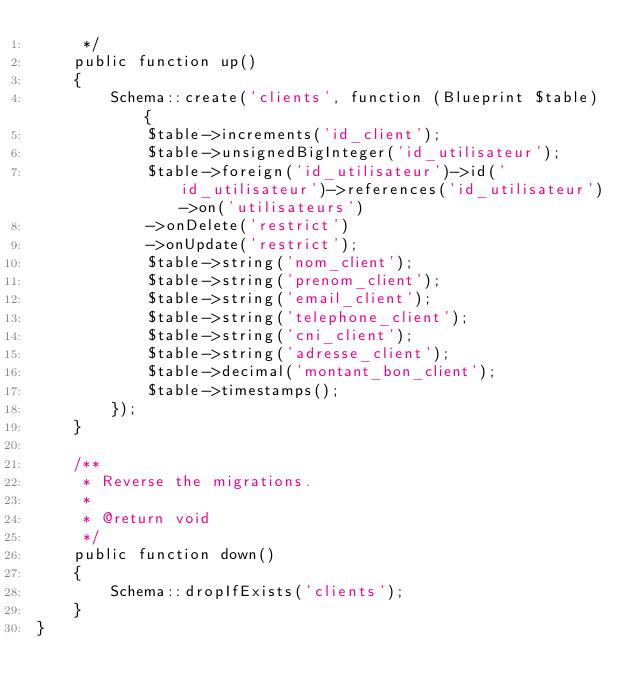<code> <loc_0><loc_0><loc_500><loc_500><_PHP_>     */
    public function up()
    {
        Schema::create('clients', function (Blueprint $table) {
            $table->increments('id_client');
            $table->unsignedBigInteger('id_utilisateur');
            $table->foreign('id_utilisateur')->id('id_utilisateur')->references('id_utilisateur')->on('utilisateurs')
            ->onDelete('restrict')
            ->onUpdate('restrict');
            $table->string('nom_client');
            $table->string('prenom_client');
            $table->string('email_client');
            $table->string('telephone_client');
            $table->string('cni_client');
            $table->string('adresse_client');
            $table->decimal('montant_bon_client');
            $table->timestamps();
        });
    }

    /**
     * Reverse the migrations.
     *
     * @return void
     */
    public function down()
    {
        Schema::dropIfExists('clients');
    }
}
</code> 